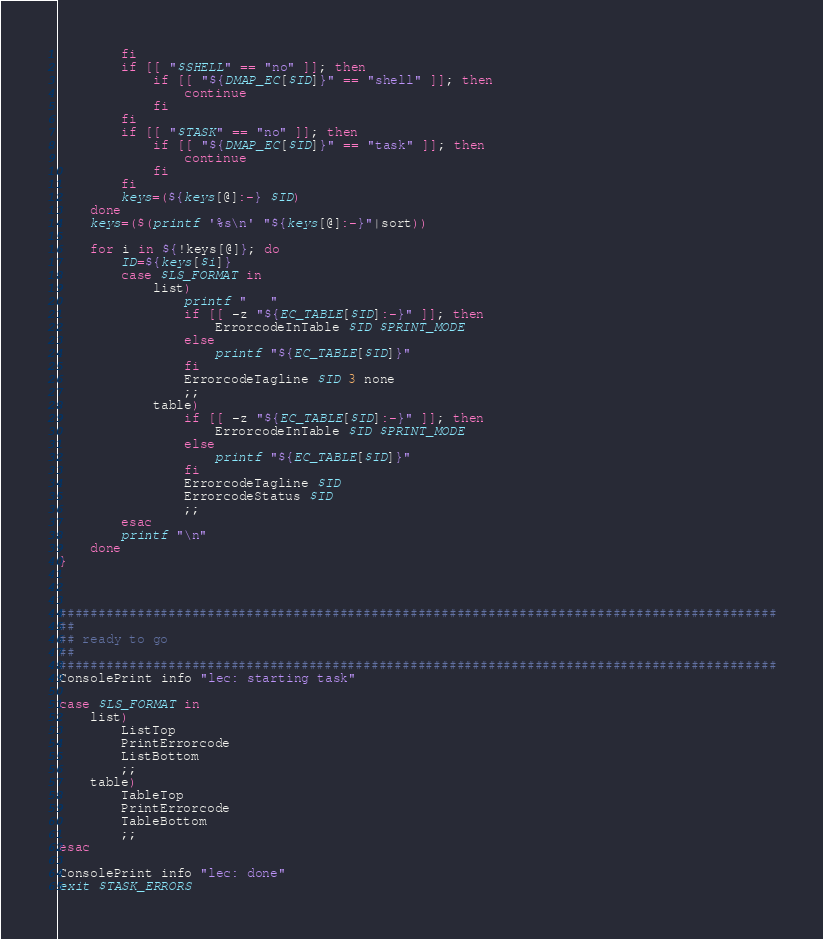Convert code to text. <code><loc_0><loc_0><loc_500><loc_500><_Bash_>        fi
        if [[ "$SHELL" == "no" ]]; then
            if [[ "${DMAP_EC[$ID]}" == "shell" ]]; then
                continue
            fi
        fi
        if [[ "$TASK" == "no" ]]; then
            if [[ "${DMAP_EC[$ID]}" == "task" ]]; then
                continue
            fi
        fi
        keys=(${keys[@]:-} $ID)
    done
    keys=($(printf '%s\n' "${keys[@]:-}"|sort))

    for i in ${!keys[@]}; do
        ID=${keys[$i]}
        case $LS_FORMAT in
            list)
                printf "   "
                if [[ -z "${EC_TABLE[$ID]:-}" ]]; then
                    ErrorcodeInTable $ID $PRINT_MODE
                else
                    printf "${EC_TABLE[$ID]}"
                fi
                ErrorcodeTagline $ID 3 none
                ;;
            table)
                if [[ -z "${EC_TABLE[$ID]:-}" ]]; then
                    ErrorcodeInTable $ID $PRINT_MODE
                else
                    printf "${EC_TABLE[$ID]}"
                fi
                ErrorcodeTagline $ID
                ErrorcodeStatus $ID
                ;;
        esac
        printf "\n"
    done
}



############################################################################################
##
## ready to go
##
############################################################################################
ConsolePrint info "lec: starting task"

case $LS_FORMAT in
    list)
        ListTop
        PrintErrorcode
        ListBottom
        ;;
    table)
        TableTop
        PrintErrorcode
        TableBottom
        ;;
esac

ConsolePrint info "lec: done"
exit $TASK_ERRORS
</code> 